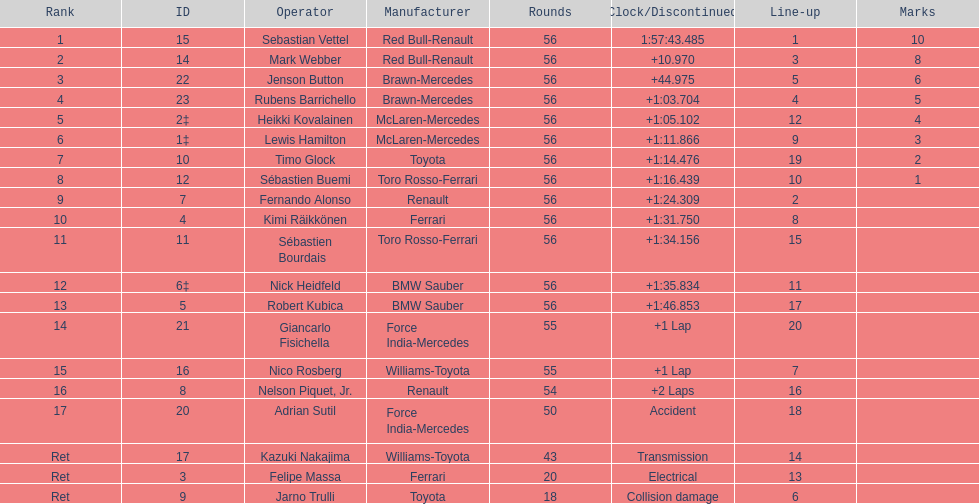What is the total number of drivers on the list? 20. 